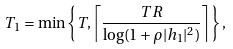<formula> <loc_0><loc_0><loc_500><loc_500>T _ { 1 } = \min \left \{ T , \left \lceil \frac { T R } { \log ( 1 + \rho | h _ { 1 } | ^ { 2 } ) } \right \rceil \right \} ,</formula> 